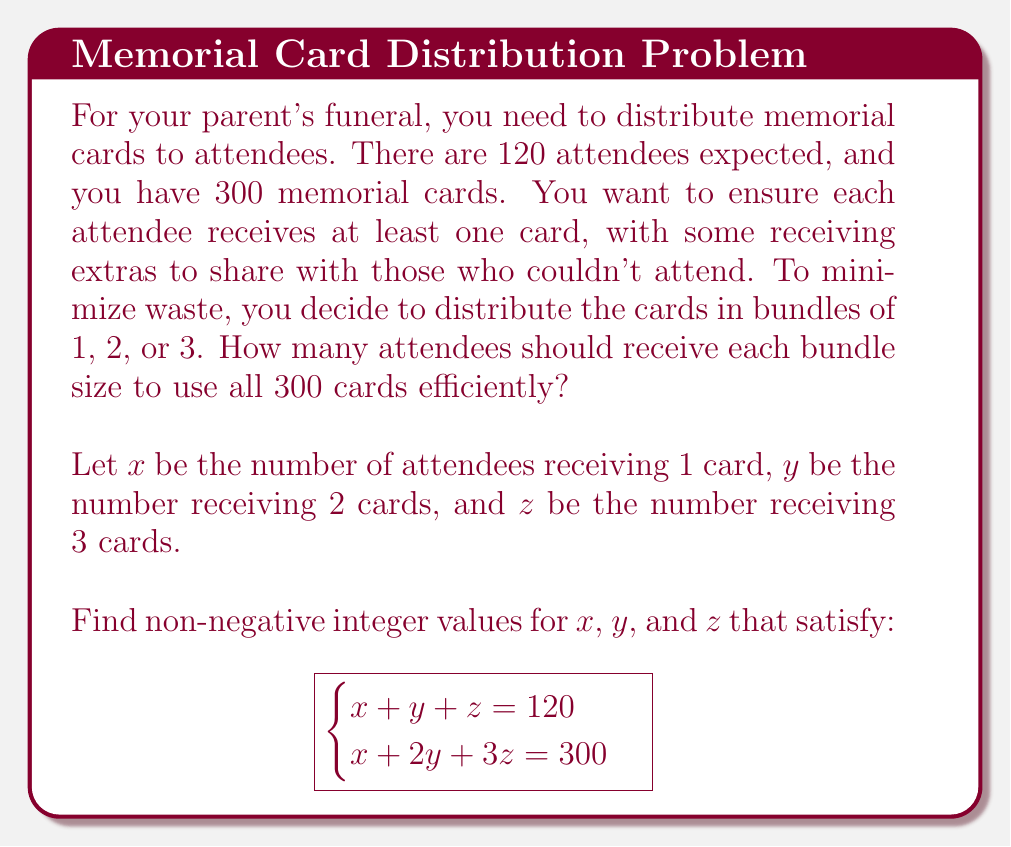Can you solve this math problem? Let's solve this system of equations step by step:

1) We have two equations:
   $$x + y + z = 120$$ (total attendees)
   $$x + 2y + 3z = 300$$ (total cards)

2) Subtract the first equation from the second:
   $$y + 2z = 180$$

3) We can express $y$ in terms of $z$:
   $$y = 180 - 2z$$

4) Substitute this into the first equation:
   $$x + (180 - 2z) + z = 120$$
   $$x + 180 - z = 120$$
   $$x = -60 + z$$

5) Since $x$, $y$, and $z$ must be non-negative integers, we can determine the possible range for $z$:
   - For $x$ to be non-negative: $z \geq 60$
   - For $y$ to be non-negative: $180 - 2z \geq 0$, so $z \leq 90$

6) Therefore, $60 \leq z \leq 90$

7) We can now check integer values for $z$ in this range:
   If $z = 60$: $x = 0$, $y = 60$, which satisfies all conditions
   
8) Verify:
   $0 + 60 + 60 = 120$ (attendees)
   $0 + 2(60) + 3(60) = 300$ (cards)

Therefore, the solution is: 60 attendees receive 2 cards, and 60 attendees receive 3 cards.
Answer: $x = 0$, $y = 60$, $z = 60$ 